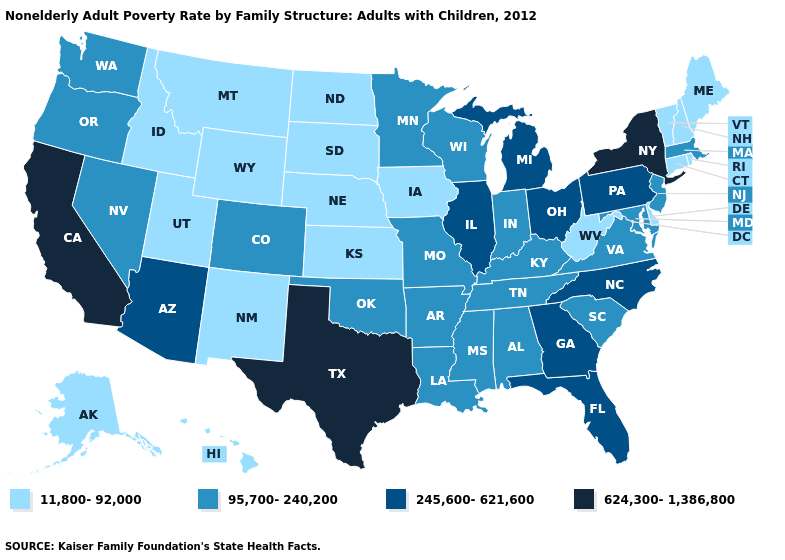What is the lowest value in the West?
Write a very short answer. 11,800-92,000. Does Utah have the highest value in the USA?
Answer briefly. No. Name the states that have a value in the range 245,600-621,600?
Concise answer only. Arizona, Florida, Georgia, Illinois, Michigan, North Carolina, Ohio, Pennsylvania. Does Florida have a lower value than New York?
Short answer required. Yes. Does Illinois have a lower value than New York?
Be succinct. Yes. Name the states that have a value in the range 11,800-92,000?
Be succinct. Alaska, Connecticut, Delaware, Hawaii, Idaho, Iowa, Kansas, Maine, Montana, Nebraska, New Hampshire, New Mexico, North Dakota, Rhode Island, South Dakota, Utah, Vermont, West Virginia, Wyoming. What is the highest value in the West ?
Concise answer only. 624,300-1,386,800. Name the states that have a value in the range 95,700-240,200?
Answer briefly. Alabama, Arkansas, Colorado, Indiana, Kentucky, Louisiana, Maryland, Massachusetts, Minnesota, Mississippi, Missouri, Nevada, New Jersey, Oklahoma, Oregon, South Carolina, Tennessee, Virginia, Washington, Wisconsin. What is the value of Missouri?
Concise answer only. 95,700-240,200. Name the states that have a value in the range 11,800-92,000?
Short answer required. Alaska, Connecticut, Delaware, Hawaii, Idaho, Iowa, Kansas, Maine, Montana, Nebraska, New Hampshire, New Mexico, North Dakota, Rhode Island, South Dakota, Utah, Vermont, West Virginia, Wyoming. What is the value of Wyoming?
Answer briefly. 11,800-92,000. Does New Mexico have the same value as Kansas?
Concise answer only. Yes. What is the value of Tennessee?
Answer briefly. 95,700-240,200. What is the value of Delaware?
Write a very short answer. 11,800-92,000. Among the states that border Washington , which have the lowest value?
Short answer required. Idaho. 